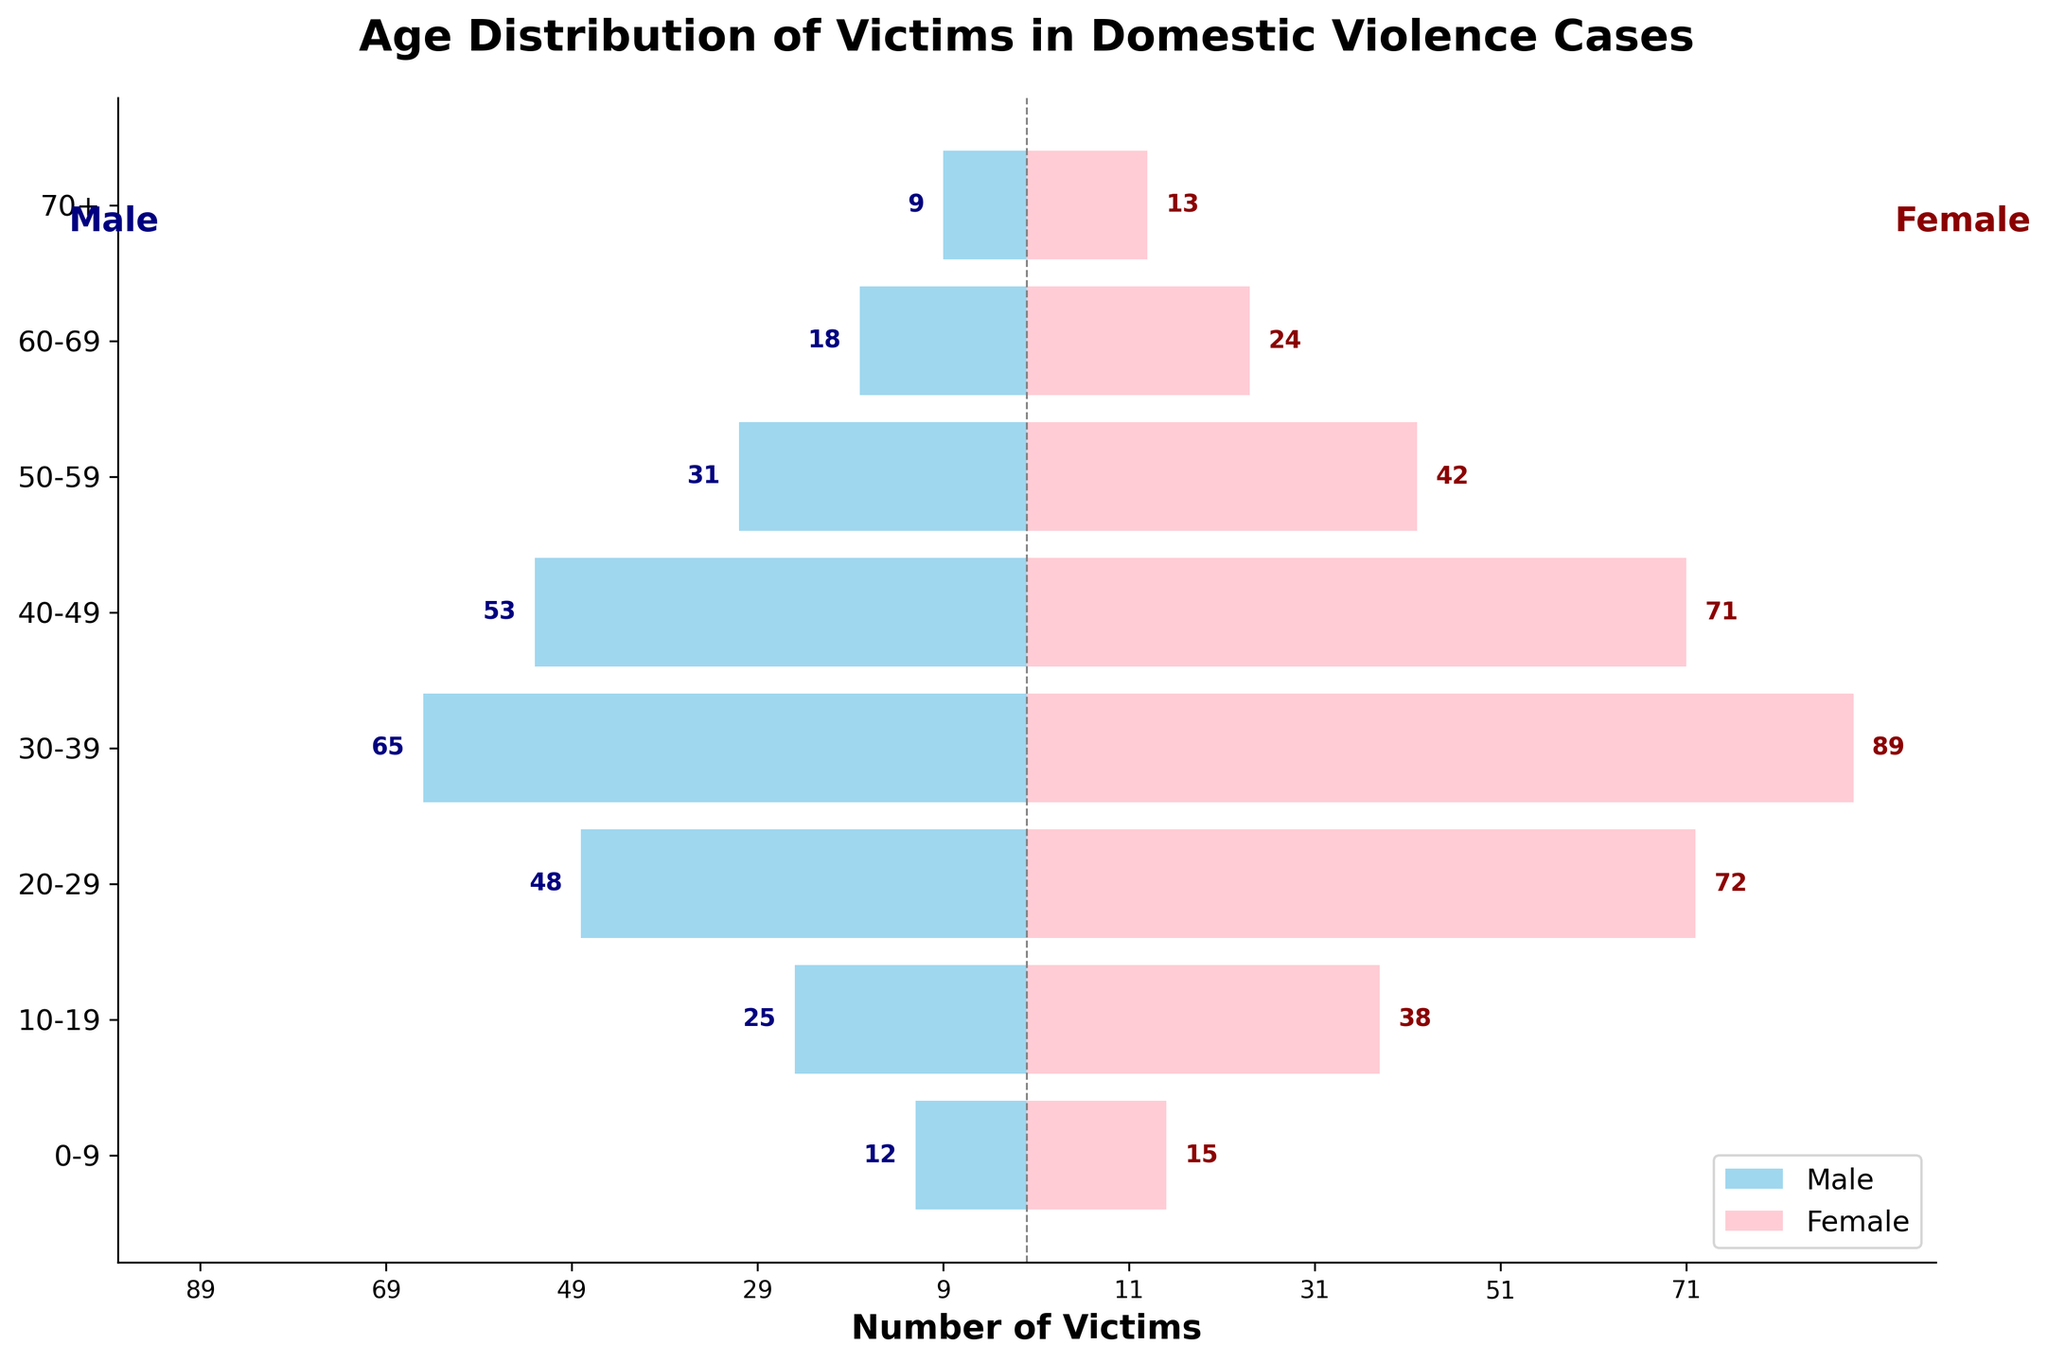What's the title of the plot? The title of the plot is written at the top center of the figure. It reads "Age Distribution of Victims in Domestic Violence Cases."
Answer: Age Distribution of Victims in Domestic Violence Cases How many age groups are represented in the plot? The y-axis of the plot has labels for each age group. By counting these labels, we find that there are 8 groups: 0-9, 10-19, 20-29, 30-39, 40-49, 50-59, 60-69, and 70+.
Answer: 8 Which gender has the highest number of victims in the 30-39 age group? In the 30-39 age group, the pink bar (female) is longer than the blue bar (male), indicating that females have a higher number of victims.
Answer: Female What is the total number of male victims in the 20-29 and 30-39 age groups combined? The number of male victims in the 20-29 age group is 48, and in the 30-39 age group is 65. By adding these two values (48 + 65), we get 113.
Answer: 113 Which age group has the lowest number of male victims? The shortest blue bar corresponds to the male victims in the 70+ age group, indicating it has the lowest number of male victims at 9.
Answer: 70+ What is the difference in the number of female victims between the 20-29 and 30-39 age groups? The number of female victims in the 20-29 age group is 72, and in the 30-39 age group is 89. By subtracting these two values (89 - 72), we get 17.
Answer: 17 In which age group(s) do the number of female victims exceed 40? By observing the pink bars corresponding to each age group, we see that the age groups 10-19, 20-29, 30-39, 40-49, and 50-59 all have pink bars extending beyond the mark of 40.
Answer: 10-19, 20-29, 30-39, 40-49, 50-59 Which age group has the most balanced number of male and female victims? The age group 60-69 has the male and female bars closest in length, indicating a more balanced number. The male victims are 18 and female victims are 24, which have a difference of 6.
Answer: 60-69 How does the number of male victims in the 40-49 age group compare to the number of female victims in the same age group? The number of male victims in the 40-49 age group is 53, whereas the number of female victims is 71. Comparing these, females outnumber males by 18.
Answer: Females outnumber males by 18 What is the average number of victims for males across all age groups? Adding the number of male victims for all age groups (12 + 25 + 48 + 65 + 53 + 31 + 18 + 9) gives a total of 261. Dividing this by the number of age groups (8) results in 261/8 = 32.625.
Answer: 32.625 